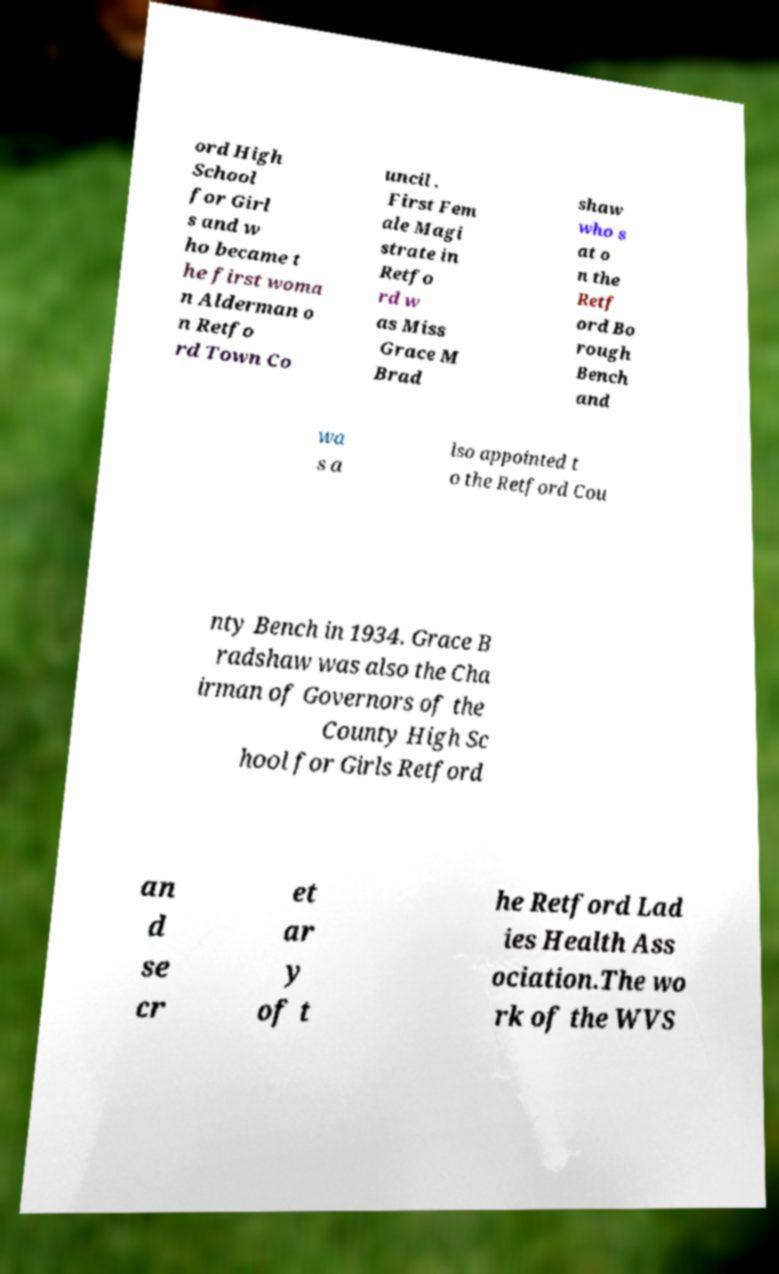Could you extract and type out the text from this image? ord High School for Girl s and w ho became t he first woma n Alderman o n Retfo rd Town Co uncil . First Fem ale Magi strate in Retfo rd w as Miss Grace M Brad shaw who s at o n the Retf ord Bo rough Bench and wa s a lso appointed t o the Retford Cou nty Bench in 1934. Grace B radshaw was also the Cha irman of Governors of the County High Sc hool for Girls Retford an d se cr et ar y of t he Retford Lad ies Health Ass ociation.The wo rk of the WVS 